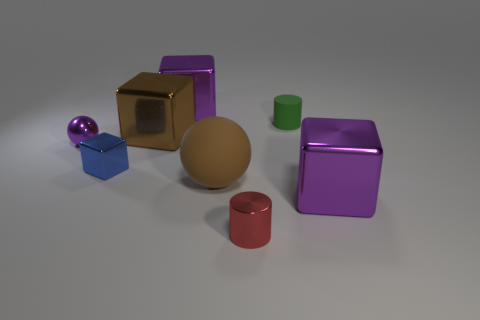Do the sphere behind the big brown ball and the cylinder right of the red cylinder have the same material?
Your answer should be very brief. No. How big is the matte object on the right side of the rubber sphere?
Ensure brevity in your answer.  Small. The matte sphere is what size?
Your response must be concise. Large. What is the size of the brown thing that is to the right of the purple cube that is behind the purple thing in front of the small purple metallic ball?
Your answer should be compact. Large. Is there a green thing made of the same material as the small red thing?
Ensure brevity in your answer.  No. There is a green matte thing; what shape is it?
Keep it short and to the point. Cylinder. What color is the cylinder that is the same material as the tiny sphere?
Your answer should be very brief. Red. What number of purple objects are metal blocks or rubber cylinders?
Provide a short and direct response. 2. Is the number of large cyan blocks greater than the number of small shiny cylinders?
Offer a terse response. No. How many objects are tiny things in front of the purple sphere or cylinders that are in front of the brown metallic cube?
Keep it short and to the point. 2. 